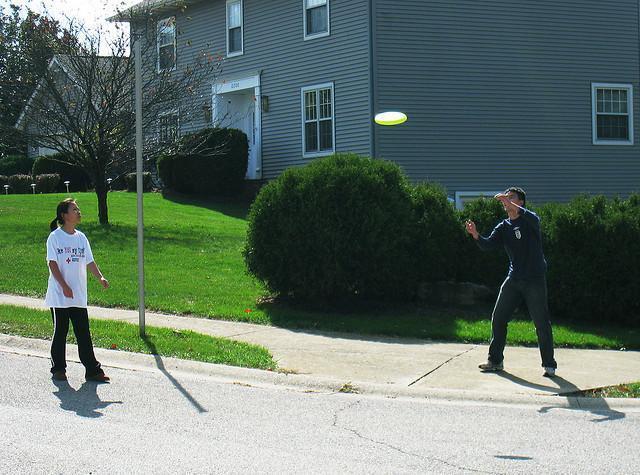How many people are there?
Give a very brief answer. 2. How many kites are in the sky?
Give a very brief answer. 0. 